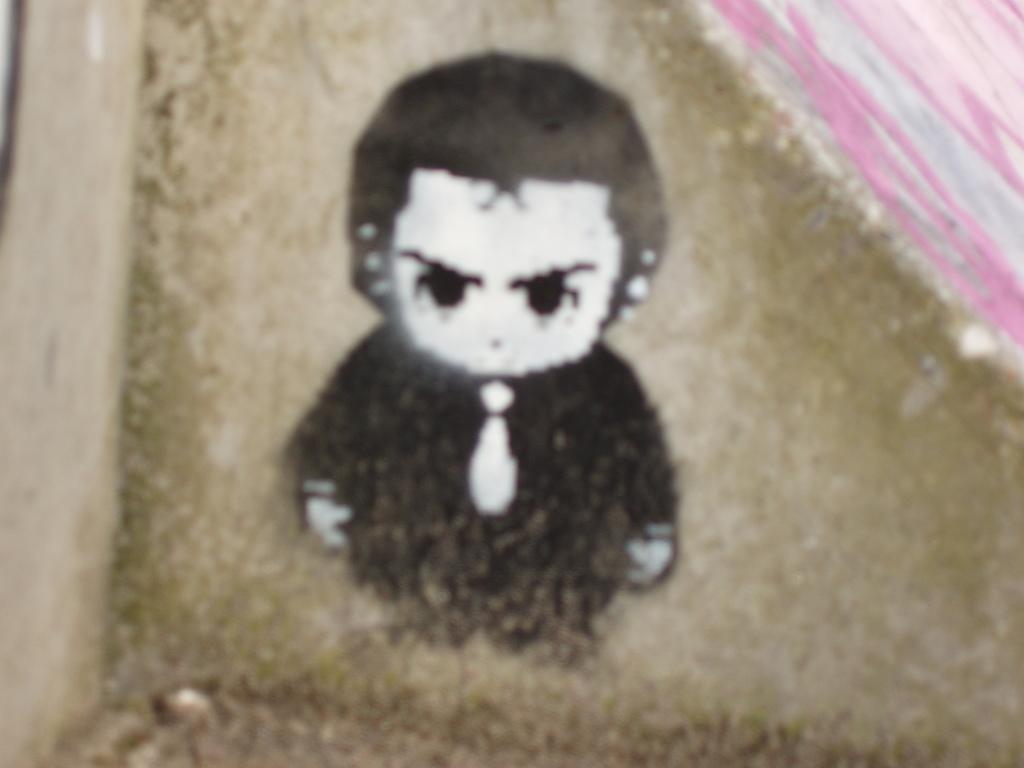Can you describe this image briefly? This image looks like a depiction of a person. And the background is colored. 